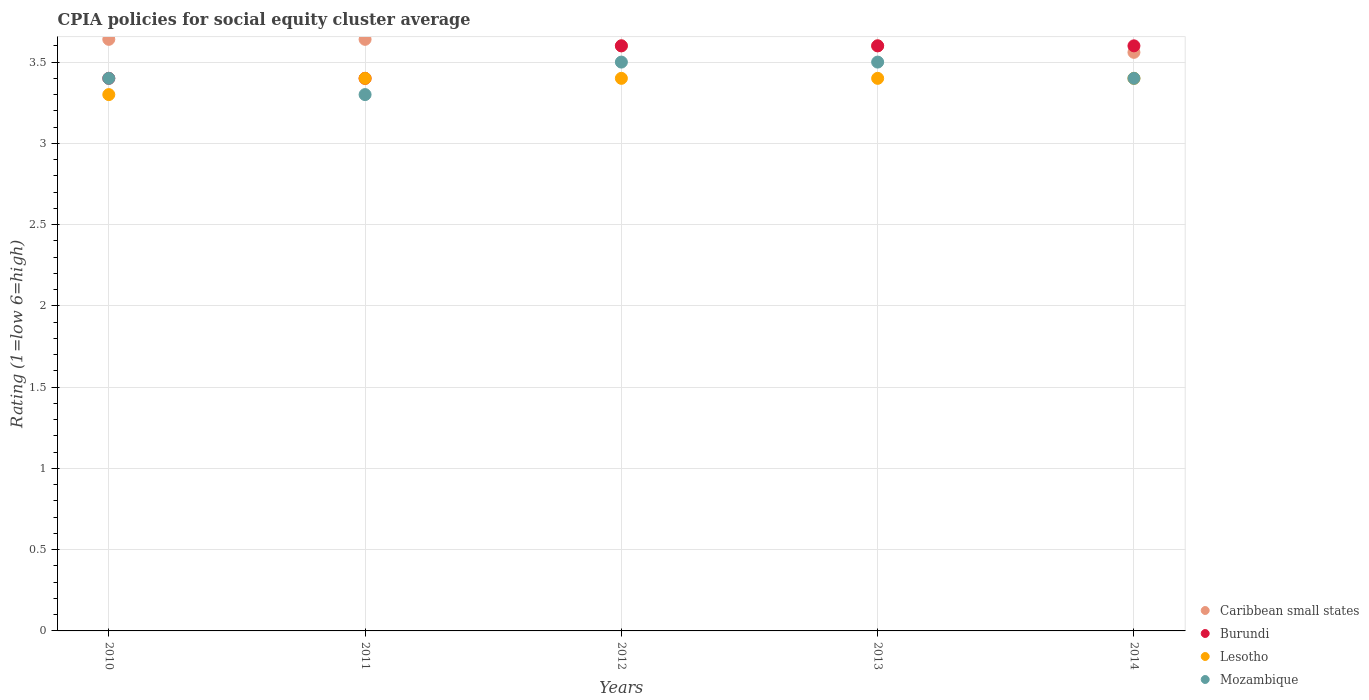How many different coloured dotlines are there?
Your answer should be very brief. 4. Is the number of dotlines equal to the number of legend labels?
Offer a terse response. Yes. Across all years, what is the maximum CPIA rating in Caribbean small states?
Your response must be concise. 3.64. In which year was the CPIA rating in Caribbean small states minimum?
Give a very brief answer. 2014. What is the total CPIA rating in Mozambique in the graph?
Provide a succinct answer. 17.1. What is the difference between the CPIA rating in Mozambique in 2010 and that in 2013?
Your response must be concise. -0.1. What is the difference between the CPIA rating in Lesotho in 2014 and the CPIA rating in Mozambique in 2010?
Your response must be concise. 0. What is the average CPIA rating in Caribbean small states per year?
Provide a short and direct response. 3.61. In the year 2014, what is the difference between the CPIA rating in Lesotho and CPIA rating in Caribbean small states?
Make the answer very short. -0.16. What is the ratio of the CPIA rating in Mozambique in 2012 to that in 2014?
Give a very brief answer. 1.03. Is the CPIA rating in Caribbean small states in 2013 less than that in 2014?
Keep it short and to the point. No. Is the difference between the CPIA rating in Lesotho in 2011 and 2012 greater than the difference between the CPIA rating in Caribbean small states in 2011 and 2012?
Offer a terse response. No. What is the difference between the highest and the second highest CPIA rating in Lesotho?
Your answer should be very brief. 0. What is the difference between the highest and the lowest CPIA rating in Burundi?
Your answer should be very brief. 0.2. Is the sum of the CPIA rating in Caribbean small states in 2010 and 2013 greater than the maximum CPIA rating in Lesotho across all years?
Provide a succinct answer. Yes. Is it the case that in every year, the sum of the CPIA rating in Mozambique and CPIA rating in Burundi  is greater than the sum of CPIA rating in Caribbean small states and CPIA rating in Lesotho?
Provide a short and direct response. No. Does the CPIA rating in Caribbean small states monotonically increase over the years?
Make the answer very short. No. Is the CPIA rating in Lesotho strictly greater than the CPIA rating in Caribbean small states over the years?
Make the answer very short. No. How many dotlines are there?
Keep it short and to the point. 4. How many years are there in the graph?
Keep it short and to the point. 5. What is the difference between two consecutive major ticks on the Y-axis?
Keep it short and to the point. 0.5. Does the graph contain any zero values?
Provide a succinct answer. No. Does the graph contain grids?
Offer a very short reply. Yes. How are the legend labels stacked?
Offer a terse response. Vertical. What is the title of the graph?
Keep it short and to the point. CPIA policies for social equity cluster average. What is the Rating (1=low 6=high) of Caribbean small states in 2010?
Ensure brevity in your answer.  3.64. What is the Rating (1=low 6=high) in Caribbean small states in 2011?
Give a very brief answer. 3.64. What is the Rating (1=low 6=high) of Burundi in 2011?
Offer a terse response. 3.4. What is the Rating (1=low 6=high) of Mozambique in 2011?
Give a very brief answer. 3.3. What is the Rating (1=low 6=high) in Caribbean small states in 2012?
Offer a terse response. 3.6. What is the Rating (1=low 6=high) of Lesotho in 2012?
Offer a very short reply. 3.4. What is the Rating (1=low 6=high) in Lesotho in 2013?
Your response must be concise. 3.4. What is the Rating (1=low 6=high) of Mozambique in 2013?
Make the answer very short. 3.5. What is the Rating (1=low 6=high) of Caribbean small states in 2014?
Provide a succinct answer. 3.56. What is the Rating (1=low 6=high) in Burundi in 2014?
Make the answer very short. 3.6. What is the Rating (1=low 6=high) of Lesotho in 2014?
Offer a terse response. 3.4. Across all years, what is the maximum Rating (1=low 6=high) of Caribbean small states?
Your response must be concise. 3.64. Across all years, what is the maximum Rating (1=low 6=high) of Burundi?
Offer a very short reply. 3.6. Across all years, what is the maximum Rating (1=low 6=high) in Lesotho?
Your response must be concise. 3.4. Across all years, what is the minimum Rating (1=low 6=high) of Caribbean small states?
Keep it short and to the point. 3.56. Across all years, what is the minimum Rating (1=low 6=high) of Burundi?
Your response must be concise. 3.4. Across all years, what is the minimum Rating (1=low 6=high) in Mozambique?
Offer a very short reply. 3.3. What is the total Rating (1=low 6=high) of Caribbean small states in the graph?
Provide a short and direct response. 18.04. What is the total Rating (1=low 6=high) of Lesotho in the graph?
Provide a short and direct response. 16.9. What is the total Rating (1=low 6=high) of Mozambique in the graph?
Offer a very short reply. 17.1. What is the difference between the Rating (1=low 6=high) in Burundi in 2010 and that in 2011?
Keep it short and to the point. 0. What is the difference between the Rating (1=low 6=high) in Lesotho in 2010 and that in 2011?
Keep it short and to the point. -0.1. What is the difference between the Rating (1=low 6=high) of Caribbean small states in 2010 and that in 2012?
Your response must be concise. 0.04. What is the difference between the Rating (1=low 6=high) in Burundi in 2010 and that in 2012?
Your answer should be compact. -0.2. What is the difference between the Rating (1=low 6=high) in Lesotho in 2010 and that in 2012?
Give a very brief answer. -0.1. What is the difference between the Rating (1=low 6=high) of Caribbean small states in 2010 and that in 2013?
Offer a very short reply. 0.04. What is the difference between the Rating (1=low 6=high) of Lesotho in 2010 and that in 2013?
Your response must be concise. -0.1. What is the difference between the Rating (1=low 6=high) of Caribbean small states in 2010 and that in 2014?
Ensure brevity in your answer.  0.08. What is the difference between the Rating (1=low 6=high) of Burundi in 2010 and that in 2014?
Your response must be concise. -0.2. What is the difference between the Rating (1=low 6=high) of Mozambique in 2010 and that in 2014?
Your response must be concise. 0. What is the difference between the Rating (1=low 6=high) of Lesotho in 2011 and that in 2012?
Provide a succinct answer. 0. What is the difference between the Rating (1=low 6=high) of Mozambique in 2011 and that in 2012?
Provide a succinct answer. -0.2. What is the difference between the Rating (1=low 6=high) of Caribbean small states in 2011 and that in 2013?
Keep it short and to the point. 0.04. What is the difference between the Rating (1=low 6=high) in Burundi in 2011 and that in 2013?
Give a very brief answer. -0.2. What is the difference between the Rating (1=low 6=high) in Lesotho in 2011 and that in 2013?
Make the answer very short. 0. What is the difference between the Rating (1=low 6=high) in Mozambique in 2011 and that in 2013?
Your answer should be very brief. -0.2. What is the difference between the Rating (1=low 6=high) in Burundi in 2011 and that in 2014?
Offer a very short reply. -0.2. What is the difference between the Rating (1=low 6=high) of Lesotho in 2011 and that in 2014?
Offer a terse response. 0. What is the difference between the Rating (1=low 6=high) of Burundi in 2012 and that in 2013?
Offer a very short reply. 0. What is the difference between the Rating (1=low 6=high) of Mozambique in 2012 and that in 2013?
Provide a short and direct response. 0. What is the difference between the Rating (1=low 6=high) in Caribbean small states in 2012 and that in 2014?
Offer a very short reply. 0.04. What is the difference between the Rating (1=low 6=high) of Lesotho in 2012 and that in 2014?
Keep it short and to the point. 0. What is the difference between the Rating (1=low 6=high) of Mozambique in 2012 and that in 2014?
Offer a terse response. 0.1. What is the difference between the Rating (1=low 6=high) of Burundi in 2013 and that in 2014?
Provide a short and direct response. 0. What is the difference between the Rating (1=low 6=high) of Lesotho in 2013 and that in 2014?
Your answer should be compact. 0. What is the difference between the Rating (1=low 6=high) in Caribbean small states in 2010 and the Rating (1=low 6=high) in Burundi in 2011?
Keep it short and to the point. 0.24. What is the difference between the Rating (1=low 6=high) in Caribbean small states in 2010 and the Rating (1=low 6=high) in Lesotho in 2011?
Give a very brief answer. 0.24. What is the difference between the Rating (1=low 6=high) of Caribbean small states in 2010 and the Rating (1=low 6=high) of Mozambique in 2011?
Give a very brief answer. 0.34. What is the difference between the Rating (1=low 6=high) in Burundi in 2010 and the Rating (1=low 6=high) in Lesotho in 2011?
Provide a short and direct response. 0. What is the difference between the Rating (1=low 6=high) in Caribbean small states in 2010 and the Rating (1=low 6=high) in Lesotho in 2012?
Your answer should be compact. 0.24. What is the difference between the Rating (1=low 6=high) in Caribbean small states in 2010 and the Rating (1=low 6=high) in Mozambique in 2012?
Offer a very short reply. 0.14. What is the difference between the Rating (1=low 6=high) in Burundi in 2010 and the Rating (1=low 6=high) in Lesotho in 2012?
Your response must be concise. 0. What is the difference between the Rating (1=low 6=high) of Burundi in 2010 and the Rating (1=low 6=high) of Mozambique in 2012?
Keep it short and to the point. -0.1. What is the difference between the Rating (1=low 6=high) in Lesotho in 2010 and the Rating (1=low 6=high) in Mozambique in 2012?
Provide a short and direct response. -0.2. What is the difference between the Rating (1=low 6=high) of Caribbean small states in 2010 and the Rating (1=low 6=high) of Burundi in 2013?
Offer a terse response. 0.04. What is the difference between the Rating (1=low 6=high) of Caribbean small states in 2010 and the Rating (1=low 6=high) of Lesotho in 2013?
Make the answer very short. 0.24. What is the difference between the Rating (1=low 6=high) of Caribbean small states in 2010 and the Rating (1=low 6=high) of Mozambique in 2013?
Your answer should be compact. 0.14. What is the difference between the Rating (1=low 6=high) of Burundi in 2010 and the Rating (1=low 6=high) of Mozambique in 2013?
Your answer should be compact. -0.1. What is the difference between the Rating (1=low 6=high) of Caribbean small states in 2010 and the Rating (1=low 6=high) of Lesotho in 2014?
Provide a succinct answer. 0.24. What is the difference between the Rating (1=low 6=high) of Caribbean small states in 2010 and the Rating (1=low 6=high) of Mozambique in 2014?
Offer a very short reply. 0.24. What is the difference between the Rating (1=low 6=high) in Burundi in 2010 and the Rating (1=low 6=high) in Lesotho in 2014?
Offer a terse response. 0. What is the difference between the Rating (1=low 6=high) of Caribbean small states in 2011 and the Rating (1=low 6=high) of Lesotho in 2012?
Offer a very short reply. 0.24. What is the difference between the Rating (1=low 6=high) in Caribbean small states in 2011 and the Rating (1=low 6=high) in Mozambique in 2012?
Make the answer very short. 0.14. What is the difference between the Rating (1=low 6=high) of Burundi in 2011 and the Rating (1=low 6=high) of Lesotho in 2012?
Your answer should be very brief. 0. What is the difference between the Rating (1=low 6=high) of Burundi in 2011 and the Rating (1=low 6=high) of Mozambique in 2012?
Provide a succinct answer. -0.1. What is the difference between the Rating (1=low 6=high) in Lesotho in 2011 and the Rating (1=low 6=high) in Mozambique in 2012?
Offer a very short reply. -0.1. What is the difference between the Rating (1=low 6=high) of Caribbean small states in 2011 and the Rating (1=low 6=high) of Burundi in 2013?
Provide a short and direct response. 0.04. What is the difference between the Rating (1=low 6=high) of Caribbean small states in 2011 and the Rating (1=low 6=high) of Lesotho in 2013?
Ensure brevity in your answer.  0.24. What is the difference between the Rating (1=low 6=high) of Caribbean small states in 2011 and the Rating (1=low 6=high) of Mozambique in 2013?
Provide a succinct answer. 0.14. What is the difference between the Rating (1=low 6=high) in Caribbean small states in 2011 and the Rating (1=low 6=high) in Lesotho in 2014?
Ensure brevity in your answer.  0.24. What is the difference between the Rating (1=low 6=high) of Caribbean small states in 2011 and the Rating (1=low 6=high) of Mozambique in 2014?
Offer a very short reply. 0.24. What is the difference between the Rating (1=low 6=high) of Burundi in 2011 and the Rating (1=low 6=high) of Lesotho in 2014?
Give a very brief answer. 0. What is the difference between the Rating (1=low 6=high) in Burundi in 2011 and the Rating (1=low 6=high) in Mozambique in 2014?
Keep it short and to the point. 0. What is the difference between the Rating (1=low 6=high) of Caribbean small states in 2012 and the Rating (1=low 6=high) of Lesotho in 2013?
Provide a succinct answer. 0.2. What is the difference between the Rating (1=low 6=high) of Burundi in 2012 and the Rating (1=low 6=high) of Lesotho in 2013?
Provide a short and direct response. 0.2. What is the difference between the Rating (1=low 6=high) of Caribbean small states in 2012 and the Rating (1=low 6=high) of Burundi in 2014?
Keep it short and to the point. 0. What is the difference between the Rating (1=low 6=high) of Caribbean small states in 2012 and the Rating (1=low 6=high) of Lesotho in 2014?
Your answer should be compact. 0.2. What is the difference between the Rating (1=low 6=high) of Burundi in 2012 and the Rating (1=low 6=high) of Lesotho in 2014?
Keep it short and to the point. 0.2. What is the difference between the Rating (1=low 6=high) of Burundi in 2012 and the Rating (1=low 6=high) of Mozambique in 2014?
Keep it short and to the point. 0.2. What is the difference between the Rating (1=low 6=high) in Lesotho in 2012 and the Rating (1=low 6=high) in Mozambique in 2014?
Your response must be concise. 0. What is the difference between the Rating (1=low 6=high) in Caribbean small states in 2013 and the Rating (1=low 6=high) in Lesotho in 2014?
Provide a succinct answer. 0.2. What is the difference between the Rating (1=low 6=high) of Caribbean small states in 2013 and the Rating (1=low 6=high) of Mozambique in 2014?
Your answer should be compact. 0.2. What is the average Rating (1=low 6=high) in Caribbean small states per year?
Offer a very short reply. 3.61. What is the average Rating (1=low 6=high) of Burundi per year?
Your answer should be compact. 3.52. What is the average Rating (1=low 6=high) in Lesotho per year?
Your answer should be compact. 3.38. What is the average Rating (1=low 6=high) in Mozambique per year?
Offer a very short reply. 3.42. In the year 2010, what is the difference between the Rating (1=low 6=high) of Caribbean small states and Rating (1=low 6=high) of Burundi?
Offer a very short reply. 0.24. In the year 2010, what is the difference between the Rating (1=low 6=high) in Caribbean small states and Rating (1=low 6=high) in Lesotho?
Ensure brevity in your answer.  0.34. In the year 2010, what is the difference between the Rating (1=low 6=high) of Caribbean small states and Rating (1=low 6=high) of Mozambique?
Provide a succinct answer. 0.24. In the year 2010, what is the difference between the Rating (1=low 6=high) in Burundi and Rating (1=low 6=high) in Lesotho?
Your answer should be very brief. 0.1. In the year 2010, what is the difference between the Rating (1=low 6=high) in Burundi and Rating (1=low 6=high) in Mozambique?
Your answer should be very brief. 0. In the year 2011, what is the difference between the Rating (1=low 6=high) in Caribbean small states and Rating (1=low 6=high) in Burundi?
Keep it short and to the point. 0.24. In the year 2011, what is the difference between the Rating (1=low 6=high) of Caribbean small states and Rating (1=low 6=high) of Lesotho?
Provide a succinct answer. 0.24. In the year 2011, what is the difference between the Rating (1=low 6=high) in Caribbean small states and Rating (1=low 6=high) in Mozambique?
Your answer should be compact. 0.34. In the year 2011, what is the difference between the Rating (1=low 6=high) of Burundi and Rating (1=low 6=high) of Lesotho?
Your answer should be compact. 0. In the year 2011, what is the difference between the Rating (1=low 6=high) of Burundi and Rating (1=low 6=high) of Mozambique?
Your answer should be compact. 0.1. In the year 2011, what is the difference between the Rating (1=low 6=high) in Lesotho and Rating (1=low 6=high) in Mozambique?
Offer a terse response. 0.1. In the year 2012, what is the difference between the Rating (1=low 6=high) of Caribbean small states and Rating (1=low 6=high) of Lesotho?
Make the answer very short. 0.2. In the year 2012, what is the difference between the Rating (1=low 6=high) of Burundi and Rating (1=low 6=high) of Lesotho?
Make the answer very short. 0.2. In the year 2012, what is the difference between the Rating (1=low 6=high) of Lesotho and Rating (1=low 6=high) of Mozambique?
Offer a very short reply. -0.1. In the year 2013, what is the difference between the Rating (1=low 6=high) in Burundi and Rating (1=low 6=high) in Lesotho?
Provide a short and direct response. 0.2. In the year 2014, what is the difference between the Rating (1=low 6=high) of Caribbean small states and Rating (1=low 6=high) of Burundi?
Make the answer very short. -0.04. In the year 2014, what is the difference between the Rating (1=low 6=high) in Caribbean small states and Rating (1=low 6=high) in Lesotho?
Your response must be concise. 0.16. In the year 2014, what is the difference between the Rating (1=low 6=high) in Caribbean small states and Rating (1=low 6=high) in Mozambique?
Your answer should be compact. 0.16. In the year 2014, what is the difference between the Rating (1=low 6=high) of Lesotho and Rating (1=low 6=high) of Mozambique?
Your response must be concise. 0. What is the ratio of the Rating (1=low 6=high) of Caribbean small states in 2010 to that in 2011?
Keep it short and to the point. 1. What is the ratio of the Rating (1=low 6=high) of Lesotho in 2010 to that in 2011?
Provide a succinct answer. 0.97. What is the ratio of the Rating (1=low 6=high) in Mozambique in 2010 to that in 2011?
Ensure brevity in your answer.  1.03. What is the ratio of the Rating (1=low 6=high) in Caribbean small states in 2010 to that in 2012?
Provide a short and direct response. 1.01. What is the ratio of the Rating (1=low 6=high) of Burundi in 2010 to that in 2012?
Give a very brief answer. 0.94. What is the ratio of the Rating (1=low 6=high) in Lesotho in 2010 to that in 2012?
Make the answer very short. 0.97. What is the ratio of the Rating (1=low 6=high) in Mozambique in 2010 to that in 2012?
Keep it short and to the point. 0.97. What is the ratio of the Rating (1=low 6=high) of Caribbean small states in 2010 to that in 2013?
Your answer should be very brief. 1.01. What is the ratio of the Rating (1=low 6=high) of Lesotho in 2010 to that in 2013?
Your answer should be very brief. 0.97. What is the ratio of the Rating (1=low 6=high) of Mozambique in 2010 to that in 2013?
Give a very brief answer. 0.97. What is the ratio of the Rating (1=low 6=high) of Caribbean small states in 2010 to that in 2014?
Your answer should be very brief. 1.02. What is the ratio of the Rating (1=low 6=high) in Lesotho in 2010 to that in 2014?
Your answer should be very brief. 0.97. What is the ratio of the Rating (1=low 6=high) in Mozambique in 2010 to that in 2014?
Your response must be concise. 1. What is the ratio of the Rating (1=low 6=high) in Caribbean small states in 2011 to that in 2012?
Provide a short and direct response. 1.01. What is the ratio of the Rating (1=low 6=high) of Mozambique in 2011 to that in 2012?
Offer a terse response. 0.94. What is the ratio of the Rating (1=low 6=high) of Caribbean small states in 2011 to that in 2013?
Provide a short and direct response. 1.01. What is the ratio of the Rating (1=low 6=high) in Lesotho in 2011 to that in 2013?
Offer a terse response. 1. What is the ratio of the Rating (1=low 6=high) in Mozambique in 2011 to that in 2013?
Give a very brief answer. 0.94. What is the ratio of the Rating (1=low 6=high) of Caribbean small states in 2011 to that in 2014?
Provide a succinct answer. 1.02. What is the ratio of the Rating (1=low 6=high) in Mozambique in 2011 to that in 2014?
Your answer should be compact. 0.97. What is the ratio of the Rating (1=low 6=high) of Burundi in 2012 to that in 2013?
Keep it short and to the point. 1. What is the ratio of the Rating (1=low 6=high) of Mozambique in 2012 to that in 2013?
Make the answer very short. 1. What is the ratio of the Rating (1=low 6=high) of Caribbean small states in 2012 to that in 2014?
Your answer should be very brief. 1.01. What is the ratio of the Rating (1=low 6=high) of Burundi in 2012 to that in 2014?
Provide a short and direct response. 1. What is the ratio of the Rating (1=low 6=high) of Mozambique in 2012 to that in 2014?
Provide a short and direct response. 1.03. What is the ratio of the Rating (1=low 6=high) in Caribbean small states in 2013 to that in 2014?
Provide a succinct answer. 1.01. What is the ratio of the Rating (1=low 6=high) in Lesotho in 2013 to that in 2014?
Your answer should be compact. 1. What is the ratio of the Rating (1=low 6=high) in Mozambique in 2013 to that in 2014?
Give a very brief answer. 1.03. What is the difference between the highest and the second highest Rating (1=low 6=high) in Caribbean small states?
Offer a very short reply. 0. What is the difference between the highest and the second highest Rating (1=low 6=high) in Lesotho?
Your response must be concise. 0. What is the difference between the highest and the second highest Rating (1=low 6=high) in Mozambique?
Provide a succinct answer. 0. What is the difference between the highest and the lowest Rating (1=low 6=high) in Burundi?
Give a very brief answer. 0.2. What is the difference between the highest and the lowest Rating (1=low 6=high) in Lesotho?
Provide a short and direct response. 0.1. What is the difference between the highest and the lowest Rating (1=low 6=high) in Mozambique?
Provide a succinct answer. 0.2. 